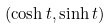Convert formula to latex. <formula><loc_0><loc_0><loc_500><loc_500>( \cosh t , \sinh t )</formula> 